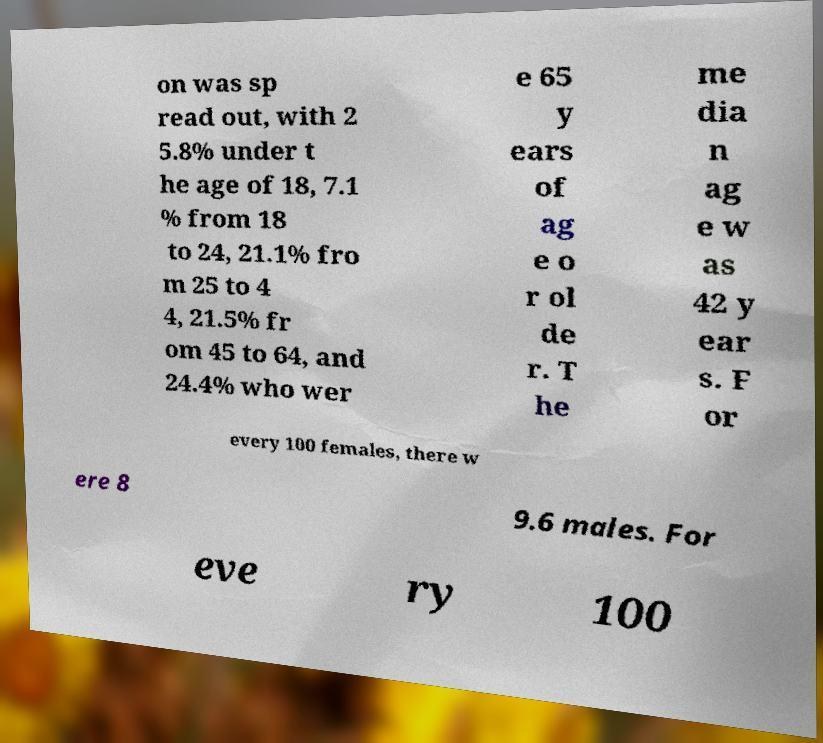Could you assist in decoding the text presented in this image and type it out clearly? on was sp read out, with 2 5.8% under t he age of 18, 7.1 % from 18 to 24, 21.1% fro m 25 to 4 4, 21.5% fr om 45 to 64, and 24.4% who wer e 65 y ears of ag e o r ol de r. T he me dia n ag e w as 42 y ear s. F or every 100 females, there w ere 8 9.6 males. For eve ry 100 